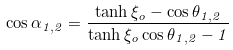<formula> <loc_0><loc_0><loc_500><loc_500>\cos \alpha _ { 1 , 2 } = \frac { \tanh \xi _ { o } - \cos \theta _ { 1 , 2 } } { \tanh \xi _ { o } \cos \theta _ { 1 , 2 } - 1 }</formula> 